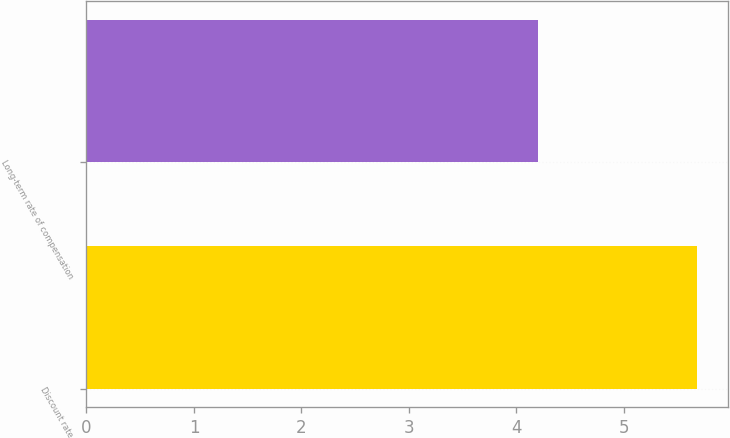<chart> <loc_0><loc_0><loc_500><loc_500><bar_chart><fcel>Discount rate<fcel>Long-term rate of compensation<nl><fcel>5.68<fcel>4.2<nl></chart> 